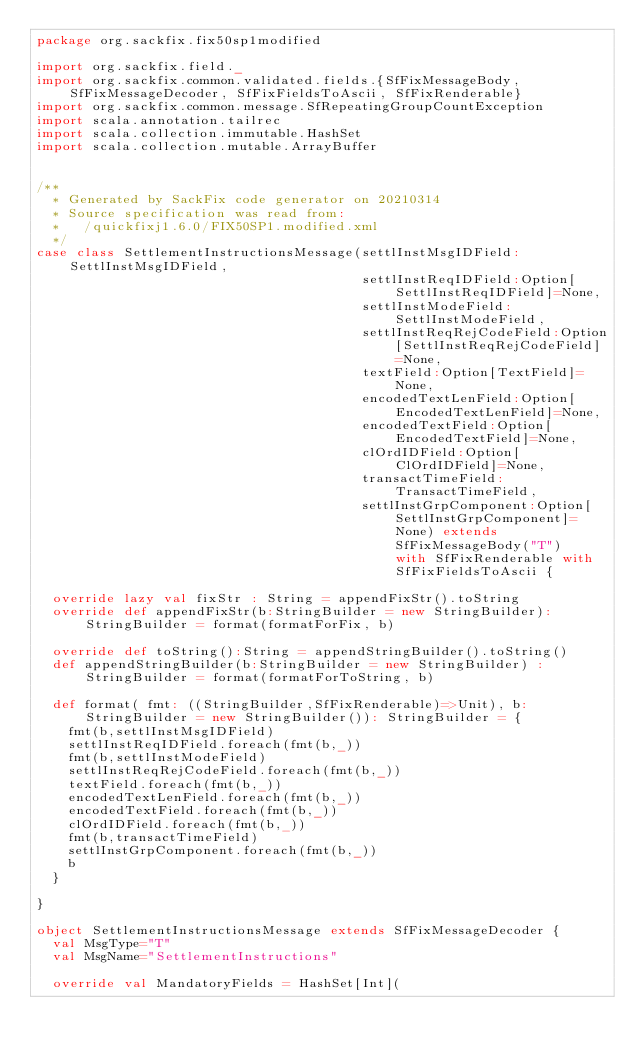<code> <loc_0><loc_0><loc_500><loc_500><_Scala_>package org.sackfix.fix50sp1modified

import org.sackfix.field._
import org.sackfix.common.validated.fields.{SfFixMessageBody, SfFixMessageDecoder, SfFixFieldsToAscii, SfFixRenderable}
import org.sackfix.common.message.SfRepeatingGroupCountException
import scala.annotation.tailrec
import scala.collection.immutable.HashSet
import scala.collection.mutable.ArrayBuffer


/**
  * Generated by SackFix code generator on 20210314
  * Source specification was read from:
  *   /quickfixj1.6.0/FIX50SP1.modified.xml
  */
case class SettlementInstructionsMessage(settlInstMsgIDField:SettlInstMsgIDField,
                                         settlInstReqIDField:Option[SettlInstReqIDField]=None,
                                         settlInstModeField:SettlInstModeField,
                                         settlInstReqRejCodeField:Option[SettlInstReqRejCodeField]=None,
                                         textField:Option[TextField]=None,
                                         encodedTextLenField:Option[EncodedTextLenField]=None,
                                         encodedTextField:Option[EncodedTextField]=None,
                                         clOrdIDField:Option[ClOrdIDField]=None,
                                         transactTimeField:TransactTimeField,
                                         settlInstGrpComponent:Option[SettlInstGrpComponent]=None) extends SfFixMessageBody("T")  with SfFixRenderable with SfFixFieldsToAscii {

  override lazy val fixStr : String = appendFixStr().toString
  override def appendFixStr(b:StringBuilder = new StringBuilder): StringBuilder = format(formatForFix, b)

  override def toString():String = appendStringBuilder().toString()
  def appendStringBuilder(b:StringBuilder = new StringBuilder) : StringBuilder = format(formatForToString, b)

  def format( fmt: ((StringBuilder,SfFixRenderable)=>Unit), b:StringBuilder = new StringBuilder()): StringBuilder = {
    fmt(b,settlInstMsgIDField)
    settlInstReqIDField.foreach(fmt(b,_))
    fmt(b,settlInstModeField)
    settlInstReqRejCodeField.foreach(fmt(b,_))
    textField.foreach(fmt(b,_))
    encodedTextLenField.foreach(fmt(b,_))
    encodedTextField.foreach(fmt(b,_))
    clOrdIDField.foreach(fmt(b,_))
    fmt(b,transactTimeField)
    settlInstGrpComponent.foreach(fmt(b,_))
    b
  }

}
     
object SettlementInstructionsMessage extends SfFixMessageDecoder {
  val MsgType="T"
  val MsgName="SettlementInstructions"
             
  override val MandatoryFields = HashSet[Int](</code> 